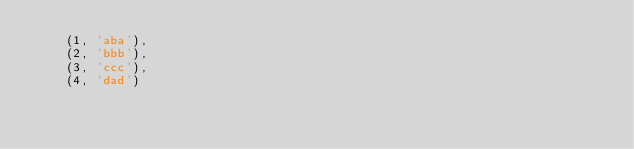Convert code to text. <code><loc_0><loc_0><loc_500><loc_500><_SQL_>    (1, 'aba'),
    (2, 'bbb'),
    (3, 'ccc'),
    (4, 'dad')
</code> 